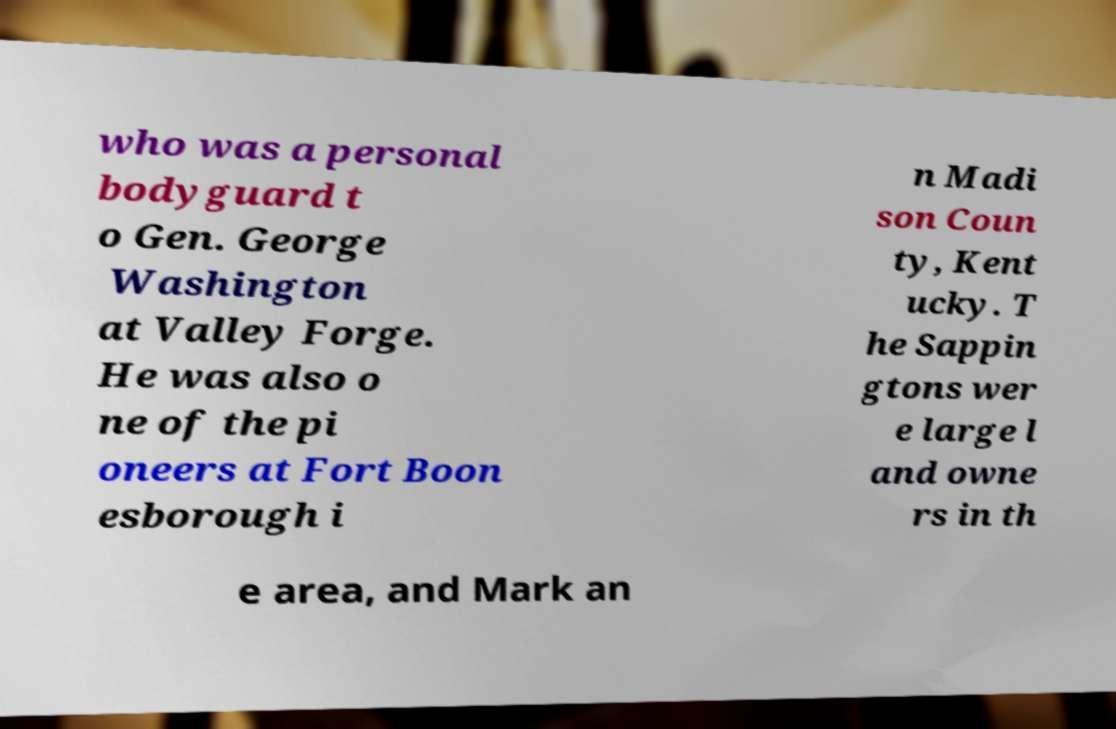There's text embedded in this image that I need extracted. Can you transcribe it verbatim? who was a personal bodyguard t o Gen. George Washington at Valley Forge. He was also o ne of the pi oneers at Fort Boon esborough i n Madi son Coun ty, Kent ucky. T he Sappin gtons wer e large l and owne rs in th e area, and Mark an 